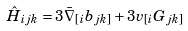Convert formula to latex. <formula><loc_0><loc_0><loc_500><loc_500>\hat { H } _ { i j k } = 3 \bar { \nabla } _ { [ i } b _ { j k ] } + 3 v _ { [ i } G _ { j k ] }</formula> 